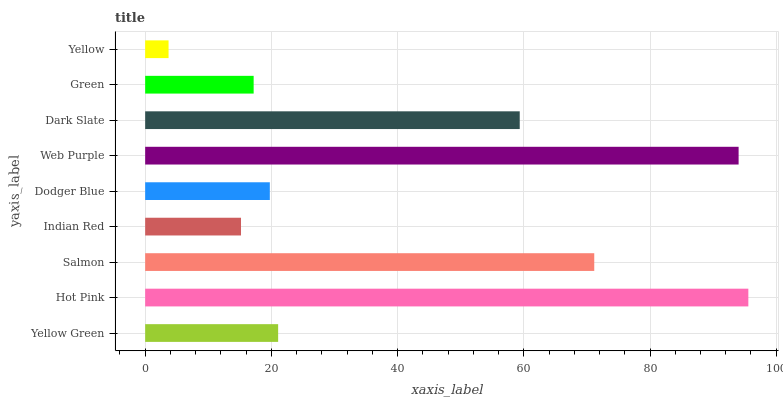Is Yellow the minimum?
Answer yes or no. Yes. Is Hot Pink the maximum?
Answer yes or no. Yes. Is Salmon the minimum?
Answer yes or no. No. Is Salmon the maximum?
Answer yes or no. No. Is Hot Pink greater than Salmon?
Answer yes or no. Yes. Is Salmon less than Hot Pink?
Answer yes or no. Yes. Is Salmon greater than Hot Pink?
Answer yes or no. No. Is Hot Pink less than Salmon?
Answer yes or no. No. Is Yellow Green the high median?
Answer yes or no. Yes. Is Yellow Green the low median?
Answer yes or no. Yes. Is Web Purple the high median?
Answer yes or no. No. Is Hot Pink the low median?
Answer yes or no. No. 